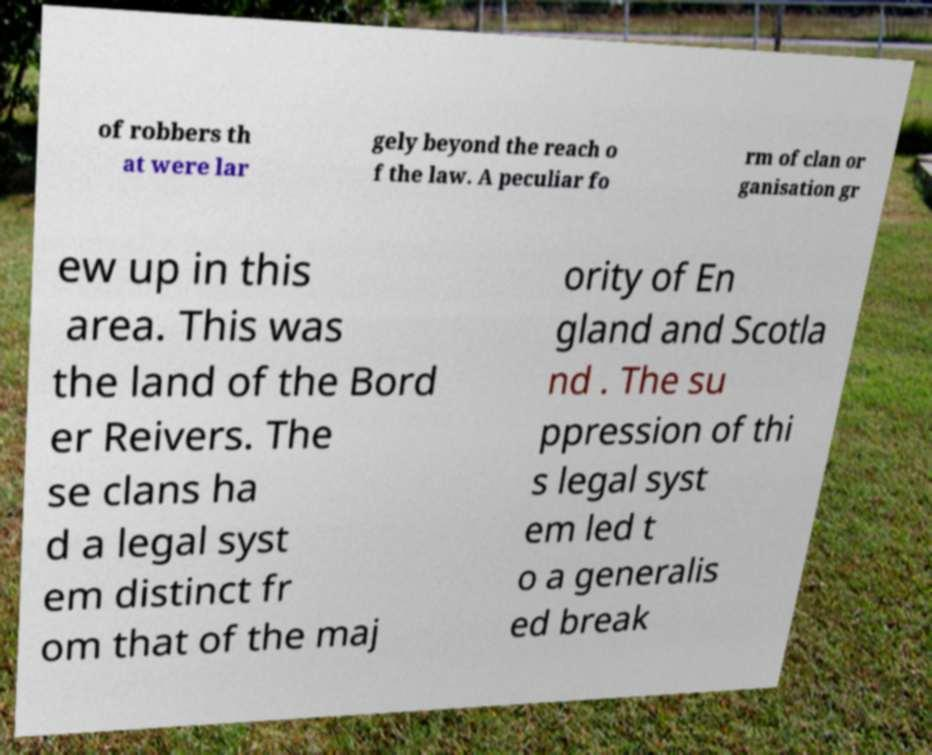Can you read and provide the text displayed in the image?This photo seems to have some interesting text. Can you extract and type it out for me? of robbers th at were lar gely beyond the reach o f the law. A peculiar fo rm of clan or ganisation gr ew up in this area. This was the land of the Bord er Reivers. The se clans ha d a legal syst em distinct fr om that of the maj ority of En gland and Scotla nd . The su ppression of thi s legal syst em led t o a generalis ed break 